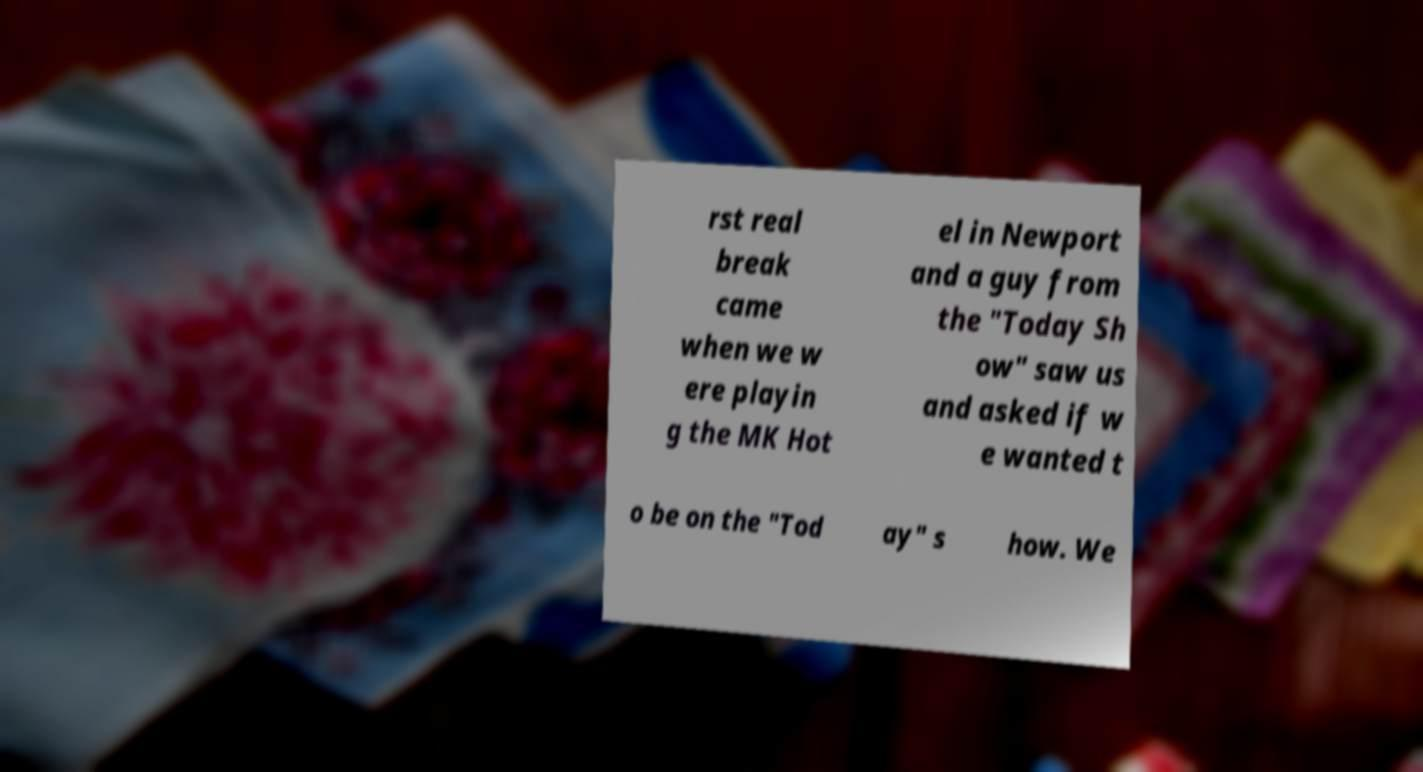Could you assist in decoding the text presented in this image and type it out clearly? rst real break came when we w ere playin g the MK Hot el in Newport and a guy from the "Today Sh ow" saw us and asked if w e wanted t o be on the "Tod ay" s how. We 